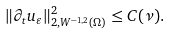Convert formula to latex. <formula><loc_0><loc_0><loc_500><loc_500>\| \partial _ { t } { u } _ { \varepsilon } \| ^ { 2 } _ { 2 , { W } ^ { - 1 , 2 } ( \Omega ) } \leq C ( \nu ) .</formula> 